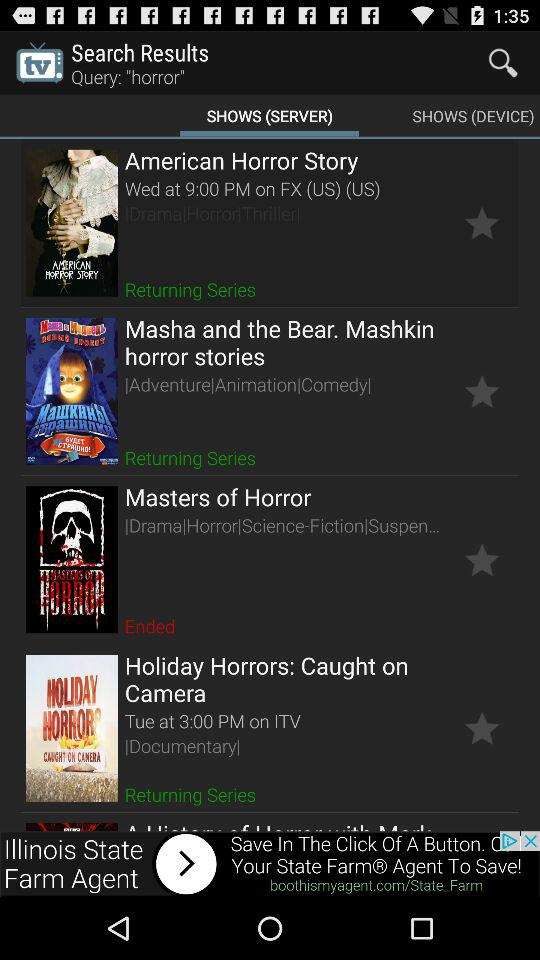What type of show is "American Horror Story"? It is a drama, horror and thriller show. 